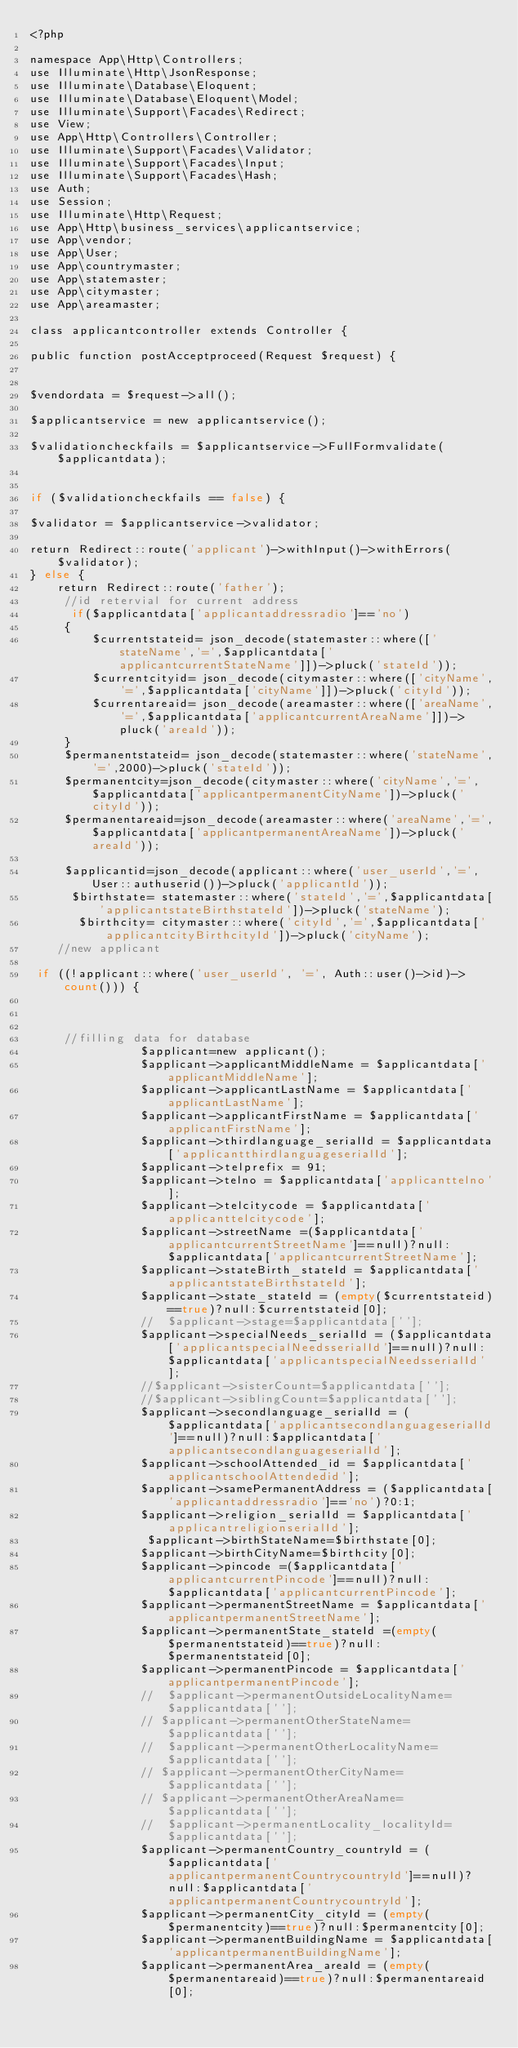Convert code to text. <code><loc_0><loc_0><loc_500><loc_500><_PHP_><?php

namespace App\Http\Controllers;
use Illuminate\Http\JsonResponse;
use Illuminate\Database\Eloquent;
use Illuminate\Database\Eloquent\Model;
use Illuminate\Support\Facades\Redirect;
use View;
use App\Http\Controllers\Controller;
use Illuminate\Support\Facades\Validator;
use Illuminate\Support\Facades\Input;
use Illuminate\Support\Facades\Hash;
use Auth;
use Session;
use Illuminate\Http\Request;
use App\Http\business_services\applicantservice;
use App\vendor;
use App\User;
use App\countrymaster;
use App\statemaster;
use App\citymaster;
use App\areamaster;

class applicantcontroller extends Controller {

public function postAcceptproceed(Request $request) {


$vendordata = $request->all();

$applicantservice = new applicantservice();

$validationcheckfails = $applicantservice->FullFormvalidate($applicantdata);


if ($validationcheckfails == false) {

$validator = $applicantservice->validator;

return Redirect::route('applicant')->withInput()->withErrors($validator);
} else { 
    return Redirect::route('father');
     //id retervial for current address
      if($applicantdata['applicantaddressradio']=='no')
     {
         $currentstateid= json_decode(statemaster::where(['stateName','=',$applicantdata['applicantcurrentStateName']])->pluck('stateId'));
         $currentcityid= json_decode(citymaster::where(['cityName','=',$applicantdata['cityName']])->pluck('cityId'));
         $currentareaid= json_decode(areamaster::where(['areaName','=',$applicantdata['applicantcurrentAreaName']])->pluck('areaId'));
     }
     $permanentstateid= json_decode(statemaster::where('stateName','=',2000)->pluck('stateId'));
     $permanentcity=json_decode(citymaster::where('cityName','=',$applicantdata['applicantpermanentCityName'])->pluck('cityId'));
     $permanentareaid=json_decode(areamaster::where('areaName','=',$applicantdata['applicantpermanentAreaName'])->pluck('areaId'));
    
     $applicantid=json_decode(applicant::where('user_userId','=',User::authuserid())->pluck('applicantId'));
      $birthstate= statemaster::where('stateId','=',$applicantdata['applicantstateBirthstateId'])->pluck('stateName');
       $birthcity= citymaster::where('cityId','=',$applicantdata['applicantcityBirthcityId'])->pluck('cityName');   
    //new applicant
       
 if ((!applicant::where('user_userId', '=', Auth::user()->id)->count())) {

  
   
     //filling data for database
                $applicant=new applicant();    
                $applicant->applicantMiddleName = $applicantdata['applicantMiddleName'];
                $applicant->applicantLastName = $applicantdata['applicantLastName'];
                $applicant->applicantFirstName = $applicantdata['applicantFirstName'];
                $applicant->thirdlanguage_serialId = $applicantdata['applicantthirdlanguageserialId'];
                $applicant->telprefix = 91;
                $applicant->telno = $applicantdata['applicanttelno'];
                $applicant->telcitycode = $applicantdata['applicanttelcitycode'];
                $applicant->streetName =($applicantdata['applicantcurrentStreetName']==null)?null:$applicantdata['applicantcurrentStreetName'];
                $applicant->stateBirth_stateId = $applicantdata['applicantstateBirthstateId'];
                $applicant->state_stateId = (empty($currentstateid)==true)?null:$currentstateid[0];
                //  $applicant->stage=$applicantdata[''];
                $applicant->specialNeeds_serialId = ($applicantdata['applicantspecialNeedsserialId']==null)?null:$applicantdata['applicantspecialNeedsserialId'];
                //$applicant->sisterCount=$applicantdata[''];
                //$applicant->siblingCount=$applicantdata[''];
                $applicant->secondlanguage_serialId = ($applicantdata['applicantsecondlanguageserialId']==null)?null:$applicantdata['applicantsecondlanguageserialId'];
                $applicant->schoolAttended_id = $applicantdata['applicantschoolAttendedid'];
                $applicant->samePermanentAddress = ($applicantdata['applicantaddressradio']=='no')?0:1;
                $applicant->religion_serialId = $applicantdata['applicantreligionserialId'];
                 $applicant->birthStateName=$birthstate[0];
                $applicant->birthCityName=$birthcity[0];      
                $applicant->pincode =($applicantdata['applicantcurrentPincode']==null)?null:$applicantdata['applicantcurrentPincode'];
                $applicant->permanentStreetName = $applicantdata['applicantpermanentStreetName'];
                $applicant->permanentState_stateId =(empty($permanentstateid)==true)?null:$permanentstateid[0];
                $applicant->permanentPincode = $applicantdata['applicantpermanentPincode'];
                //  $applicant->permanentOutsideLocalityName=$applicantdata[''];
                // $applicant->permanentOtherStateName=$applicantdata[''];
                //  $applicant->permanentOtherLocalityName=$applicantdata[''];
                // $applicant->permanentOtherCityName=$applicantdata[''];
                // $applicant->permanentOtherAreaName=$applicantdata[''];
                //  $applicant->permanentLocality_localityId=$applicantdata[''];
                $applicant->permanentCountry_countryId = ($applicantdata['applicantpermanentCountrycountryId']==null)?null:$applicantdata['applicantpermanentCountrycountryId'];
                $applicant->permanentCity_cityId = (empty($permanentcity)==true)?null:$permanentcity[0];
                $applicant->permanentBuildingName = $applicantdata['applicantpermanentBuildingName'];
                $applicant->permanentArea_areaId = (empty($permanentareaid)==true)?null:$permanentareaid[0];</code> 